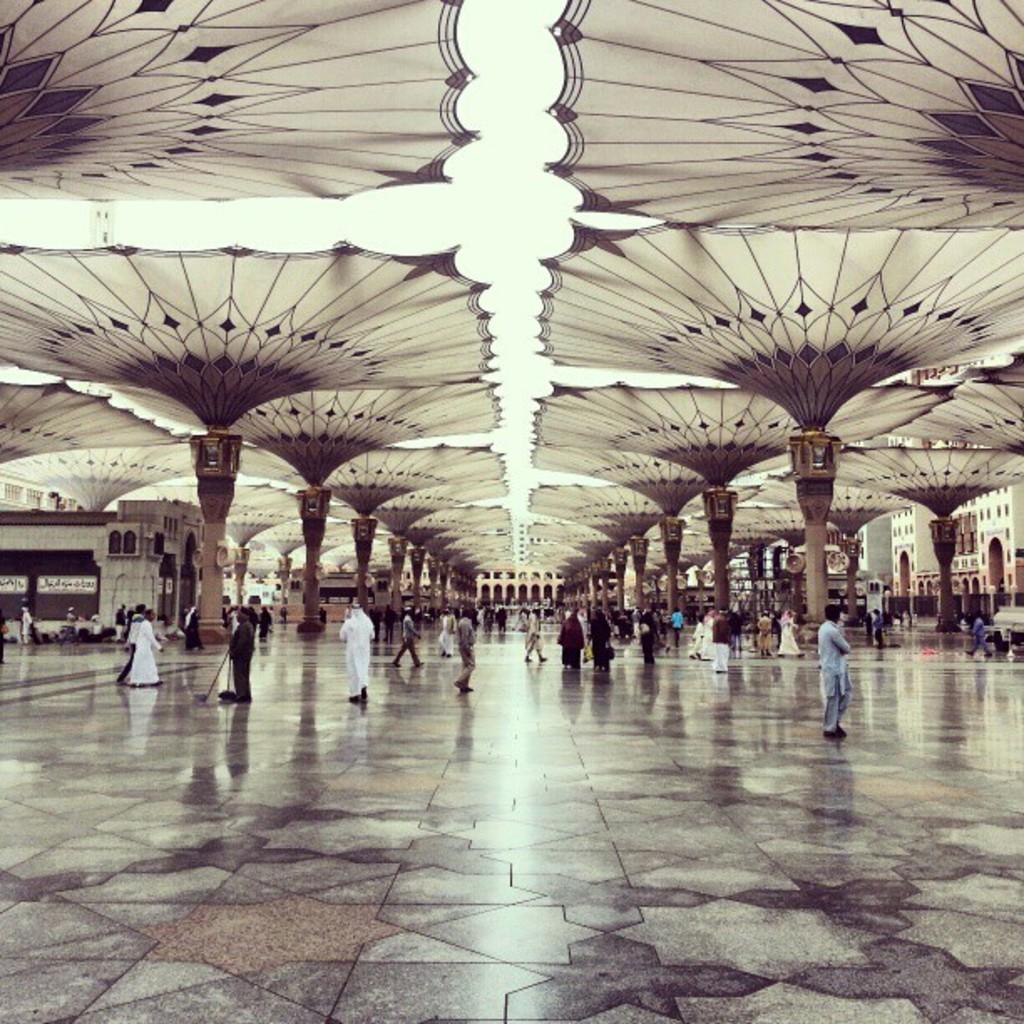Can you describe this image briefly? In this image there are so many people walking on the floor under the tents. 